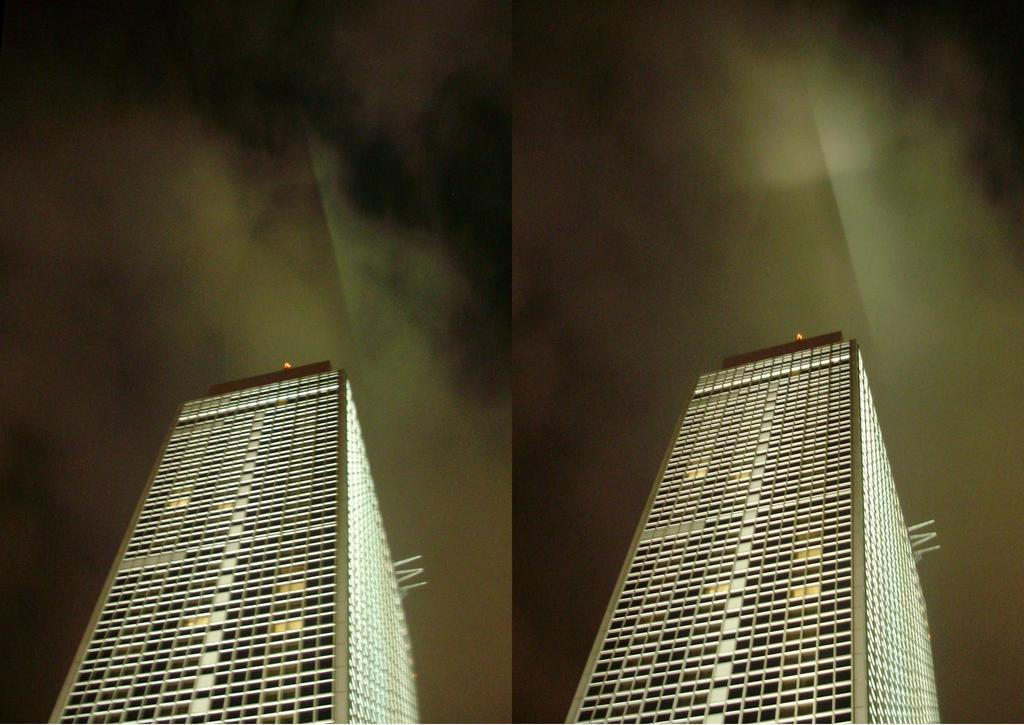What type of artwork is the image? The image is a collage. What structures are depicted in the collage? There are buildings in the image. What part of the natural environment is visible in the collage? The sky is visible in the image. What type of muscle can be seen flexing in the image? There is no muscle visible in the image; it is a collage featuring buildings and the sky. 